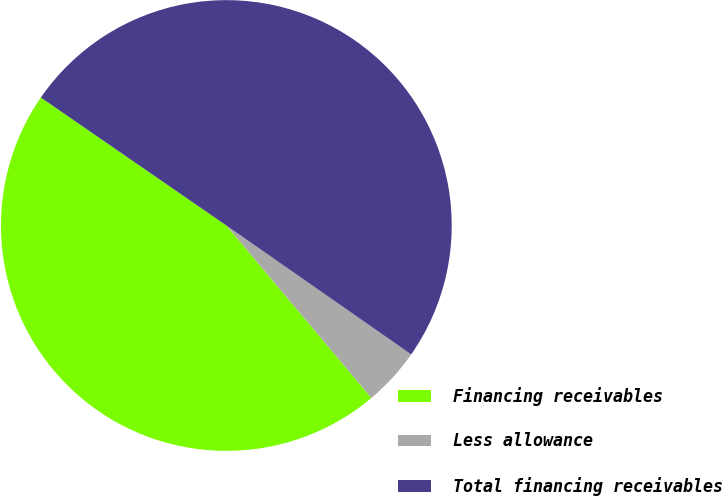Convert chart. <chart><loc_0><loc_0><loc_500><loc_500><pie_chart><fcel>Financing receivables<fcel>Less allowance<fcel>Total financing receivables<nl><fcel>45.74%<fcel>4.18%<fcel>50.08%<nl></chart> 